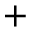Convert formula to latex. <formula><loc_0><loc_0><loc_500><loc_500>+</formula> 